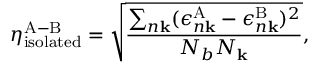Convert formula to latex. <formula><loc_0><loc_0><loc_500><loc_500>\eta _ { i s o l a t e d } ^ { A - B } = \sqrt { \frac { \sum _ { n k } ( \epsilon _ { n k } ^ { A } - \epsilon _ { n k } ^ { B } ) ^ { 2 } } { N _ { b } N _ { k } } } ,</formula> 